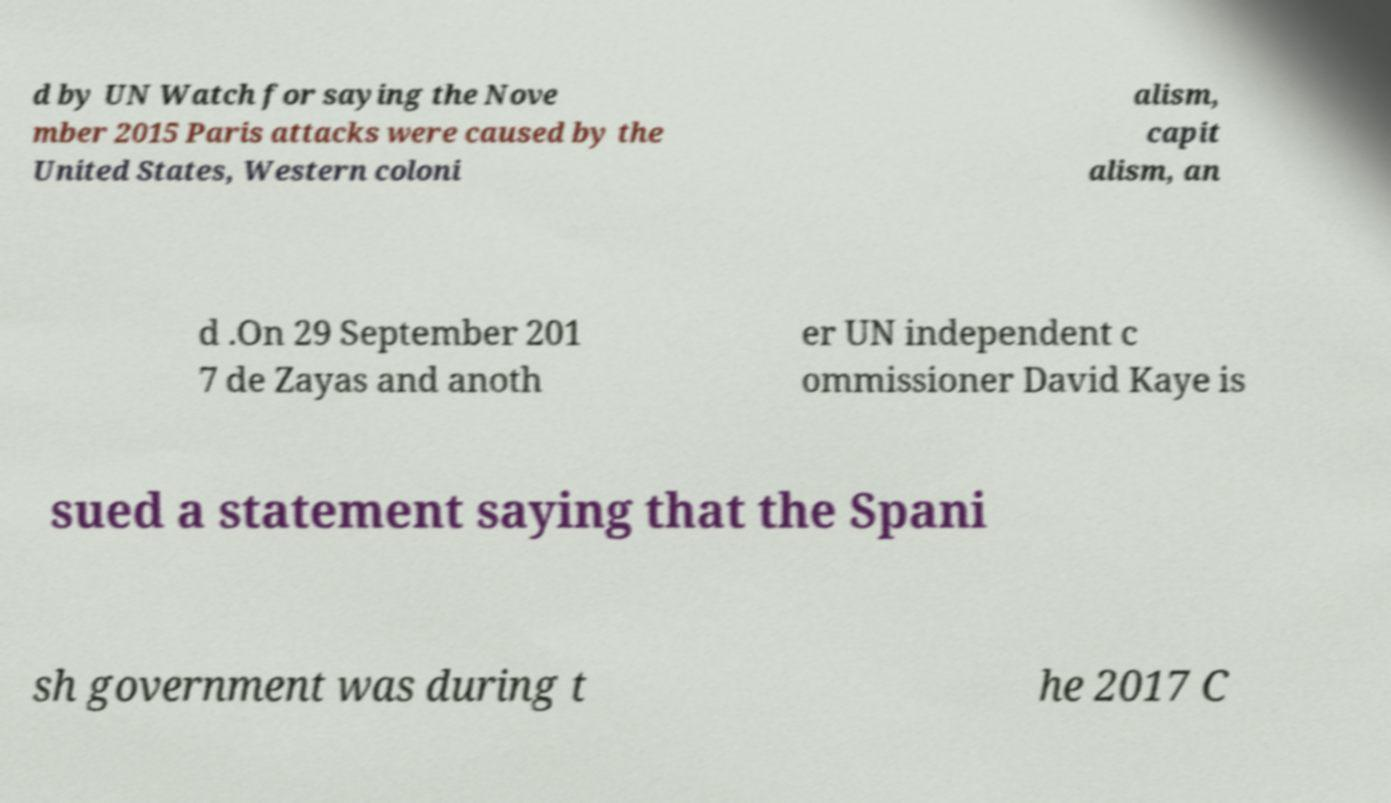For documentation purposes, I need the text within this image transcribed. Could you provide that? d by UN Watch for saying the Nove mber 2015 Paris attacks were caused by the United States, Western coloni alism, capit alism, an d .On 29 September 201 7 de Zayas and anoth er UN independent c ommissioner David Kaye is sued a statement saying that the Spani sh government was during t he 2017 C 